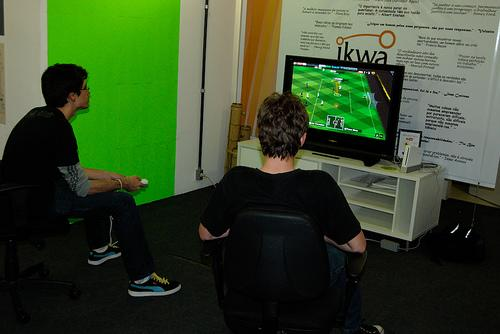What is the white thing the man is holding? Please explain your reasoning. game remote. As you can see by the picture they are playing the wii and that white controller allows you to play. 